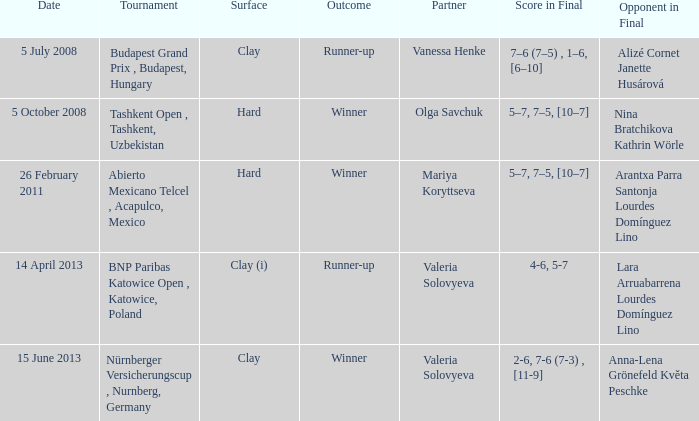Name the outcome for alizé cornet janette husárová being opponent in final Runner-up. 